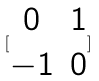<formula> <loc_0><loc_0><loc_500><loc_500>[ \begin{matrix} 0 & 1 \\ - 1 & 0 \end{matrix} ]</formula> 